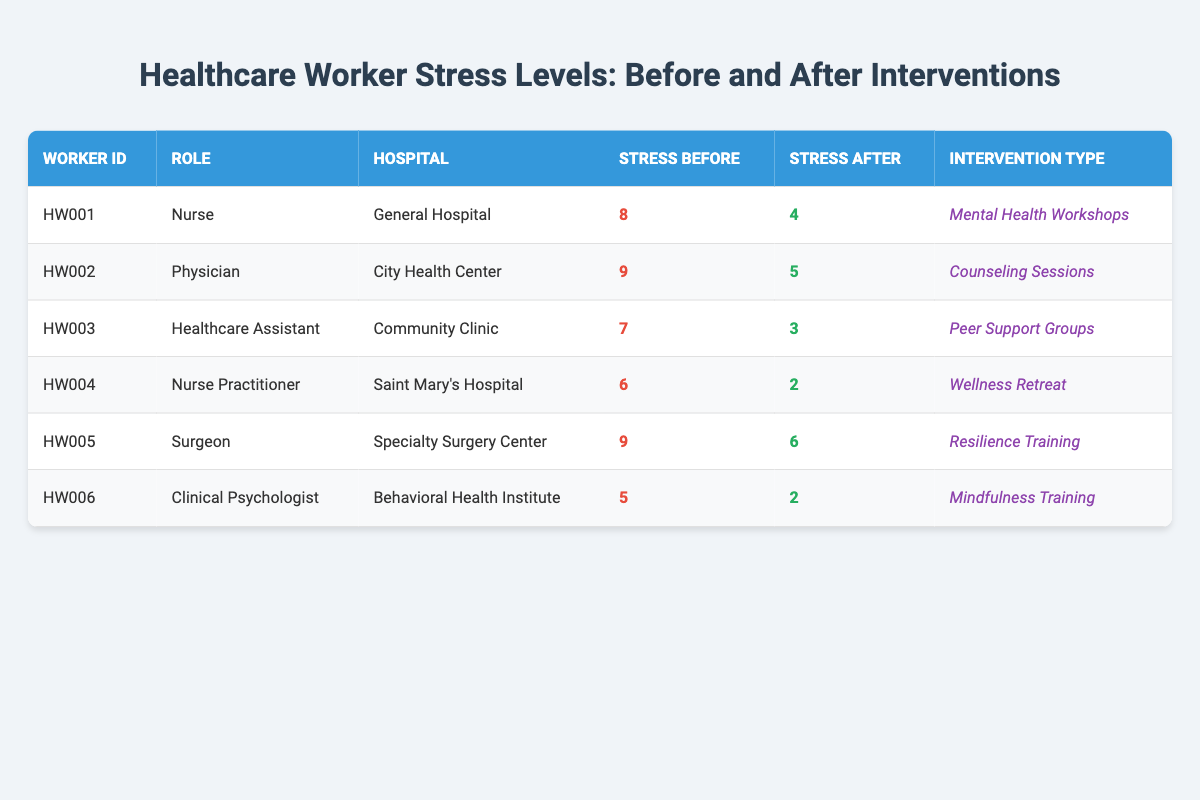What was the stress level for the healthcare assistant before the intervention? According to the table, the stress level for the healthcare assistant (HW003) before the intervention was 7.
Answer: 7 Which intervention led to the largest reduction in stress levels? To find the largest reduction, we compare the differences in stress levels before and after each intervention. The reductions are as follows: Mental Health Workshops (8 to 4 = 4), Counseling Sessions (9 to 5 = 4), Peer Support Groups (7 to 3 = 4), Wellness Retreat (6 to 2 = 4), Resilience Training (9 to 6 = 3), and Mindfulness Training (5 to 2 = 3). The largest reductions of 4 occurred for Mental Health Workshops, Counseling Sessions, Peer Support Groups, and Wellness Retreat.
Answer: Mental Health Workshops, Counseling Sessions, Peer Support Groups, Wellness Retreat Did any healthcare worker experience an increase in their stress level after the intervention? By examining the stress levels after the interventions, we see that all workers have reported lower stress levels; therefore, no healthcare worker experienced an increase in their stress level after the intervention.
Answer: No What is the average stress level before interventions across all workers? To calculate the average stress level before interventions, we sum the stress levels before each intervention: 8 + 9 + 7 + 6 + 9 + 5 = 44. There are 6 workers, so the average is 44 / 6 = 7.33.
Answer: 7.33 Which role had the lowest stress level after the intervention, and what was the level? By reviewing the stress levels after the interventions, we find that the nurse practitioner (HW004) had the lowest stress level after the intervention at 2.
Answer: Nurse Practitioner, 2 What was the combined stress level before the intervention for nurses? The stress levels before interventions for nurses (HW001 and HW004) are 8 and 6, respectively. Adding them gives us a combined stress level of 8 + 6 = 14 for nurses.
Answer: 14 Is it true that all interventions resulted in stress levels below 5 after the intervention? Reviewing the stress levels after the interventions, we see that the stress levels are: 4, 5, 3, 2, 6, and 2. Since one worker reported a stress level of 6 after the intervention, it is not true that all interventions resulted in stress levels below 5.
Answer: No 